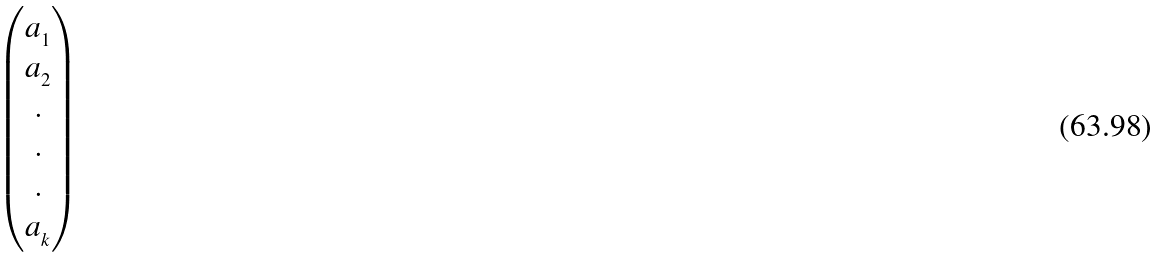Convert formula to latex. <formula><loc_0><loc_0><loc_500><loc_500>\begin{pmatrix} a _ { _ { 1 } } \\ a _ { _ { 2 } } \\ . \\ . \\ . \\ a _ { _ { k } } \\ \end{pmatrix}</formula> 